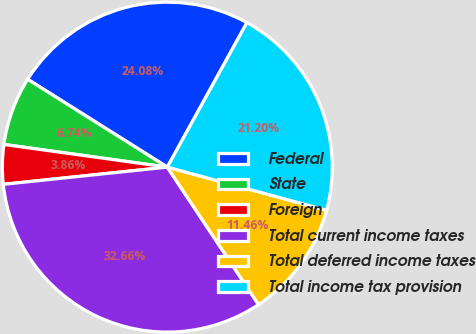Convert chart. <chart><loc_0><loc_0><loc_500><loc_500><pie_chart><fcel>Federal<fcel>State<fcel>Foreign<fcel>Total current income taxes<fcel>Total deferred income taxes<fcel>Total income tax provision<nl><fcel>24.08%<fcel>6.74%<fcel>3.86%<fcel>32.66%<fcel>11.46%<fcel>21.2%<nl></chart> 